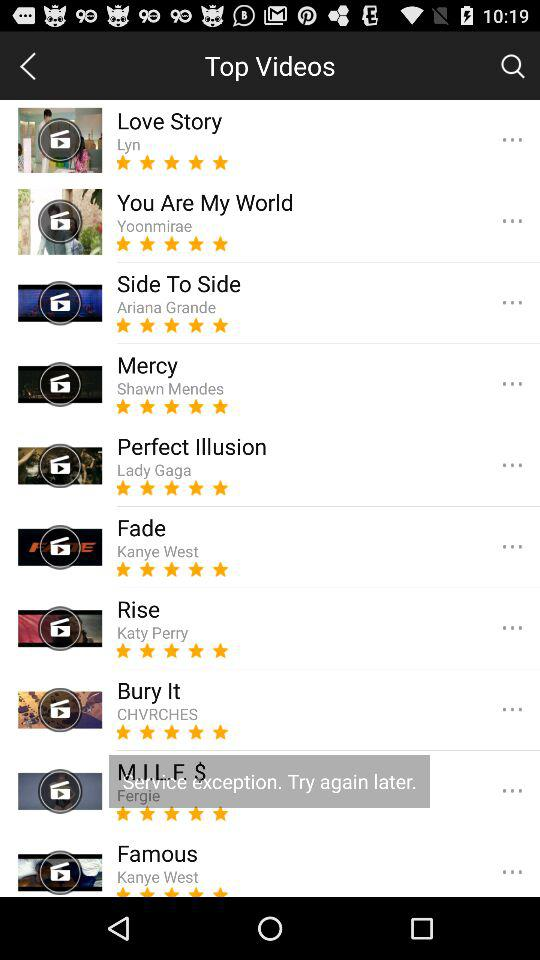Katy Perry is the singer of what song? Katy Perry is the singer of the "Rise" song. 